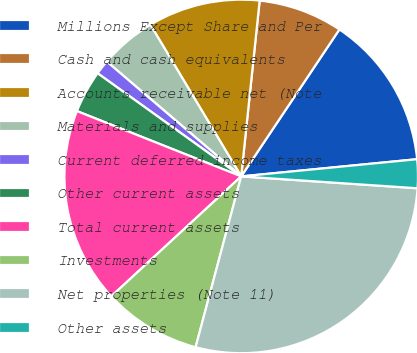Convert chart. <chart><loc_0><loc_0><loc_500><loc_500><pie_chart><fcel>Millions Except Share and Per<fcel>Cash and cash equivalents<fcel>Accounts receivable net (Note<fcel>Materials and supplies<fcel>Current deferred income taxes<fcel>Other current assets<fcel>Total current assets<fcel>Investments<fcel>Net properties (Note 11)<fcel>Other assets<nl><fcel>14.07%<fcel>7.71%<fcel>10.25%<fcel>5.16%<fcel>1.34%<fcel>3.89%<fcel>17.89%<fcel>8.98%<fcel>28.08%<fcel>2.62%<nl></chart> 